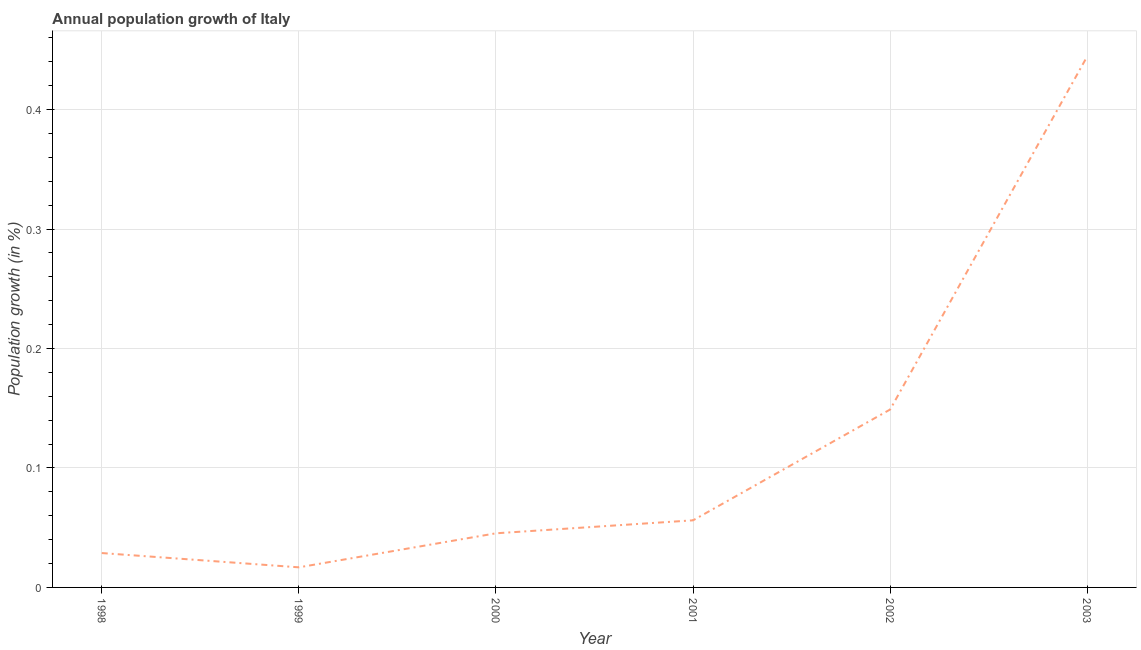What is the population growth in 2003?
Make the answer very short. 0.44. Across all years, what is the maximum population growth?
Make the answer very short. 0.44. Across all years, what is the minimum population growth?
Provide a short and direct response. 0.02. In which year was the population growth minimum?
Offer a terse response. 1999. What is the sum of the population growth?
Your response must be concise. 0.74. What is the difference between the population growth in 1998 and 2001?
Your answer should be compact. -0.03. What is the average population growth per year?
Your answer should be very brief. 0.12. What is the median population growth?
Give a very brief answer. 0.05. What is the ratio of the population growth in 2000 to that in 2001?
Keep it short and to the point. 0.81. Is the population growth in 1998 less than that in 2000?
Keep it short and to the point. Yes. Is the difference between the population growth in 1999 and 2003 greater than the difference between any two years?
Provide a short and direct response. Yes. What is the difference between the highest and the second highest population growth?
Your answer should be compact. 0.3. What is the difference between the highest and the lowest population growth?
Provide a short and direct response. 0.43. Does the graph contain any zero values?
Provide a succinct answer. No. What is the title of the graph?
Ensure brevity in your answer.  Annual population growth of Italy. What is the label or title of the X-axis?
Give a very brief answer. Year. What is the label or title of the Y-axis?
Keep it short and to the point. Population growth (in %). What is the Population growth (in %) of 1998?
Your answer should be compact. 0.03. What is the Population growth (in %) of 1999?
Keep it short and to the point. 0.02. What is the Population growth (in %) in 2000?
Offer a terse response. 0.05. What is the Population growth (in %) in 2001?
Make the answer very short. 0.06. What is the Population growth (in %) of 2002?
Ensure brevity in your answer.  0.15. What is the Population growth (in %) of 2003?
Keep it short and to the point. 0.44. What is the difference between the Population growth (in %) in 1998 and 1999?
Offer a terse response. 0.01. What is the difference between the Population growth (in %) in 1998 and 2000?
Your response must be concise. -0.02. What is the difference between the Population growth (in %) in 1998 and 2001?
Provide a succinct answer. -0.03. What is the difference between the Population growth (in %) in 1998 and 2002?
Make the answer very short. -0.12. What is the difference between the Population growth (in %) in 1998 and 2003?
Give a very brief answer. -0.42. What is the difference between the Population growth (in %) in 1999 and 2000?
Your answer should be compact. -0.03. What is the difference between the Population growth (in %) in 1999 and 2001?
Your answer should be compact. -0.04. What is the difference between the Population growth (in %) in 1999 and 2002?
Make the answer very short. -0.13. What is the difference between the Population growth (in %) in 1999 and 2003?
Ensure brevity in your answer.  -0.43. What is the difference between the Population growth (in %) in 2000 and 2001?
Provide a succinct answer. -0.01. What is the difference between the Population growth (in %) in 2000 and 2002?
Offer a terse response. -0.1. What is the difference between the Population growth (in %) in 2000 and 2003?
Provide a succinct answer. -0.4. What is the difference between the Population growth (in %) in 2001 and 2002?
Offer a very short reply. -0.09. What is the difference between the Population growth (in %) in 2001 and 2003?
Your answer should be compact. -0.39. What is the difference between the Population growth (in %) in 2002 and 2003?
Your response must be concise. -0.3. What is the ratio of the Population growth (in %) in 1998 to that in 1999?
Ensure brevity in your answer.  1.71. What is the ratio of the Population growth (in %) in 1998 to that in 2000?
Offer a very short reply. 0.64. What is the ratio of the Population growth (in %) in 1998 to that in 2001?
Ensure brevity in your answer.  0.51. What is the ratio of the Population growth (in %) in 1998 to that in 2002?
Offer a terse response. 0.19. What is the ratio of the Population growth (in %) in 1998 to that in 2003?
Your answer should be very brief. 0.07. What is the ratio of the Population growth (in %) in 1999 to that in 2000?
Provide a short and direct response. 0.37. What is the ratio of the Population growth (in %) in 1999 to that in 2001?
Offer a terse response. 0.3. What is the ratio of the Population growth (in %) in 1999 to that in 2002?
Your response must be concise. 0.11. What is the ratio of the Population growth (in %) in 1999 to that in 2003?
Ensure brevity in your answer.  0.04. What is the ratio of the Population growth (in %) in 2000 to that in 2001?
Your response must be concise. 0.81. What is the ratio of the Population growth (in %) in 2000 to that in 2002?
Your answer should be very brief. 0.3. What is the ratio of the Population growth (in %) in 2000 to that in 2003?
Provide a short and direct response. 0.1. What is the ratio of the Population growth (in %) in 2001 to that in 2002?
Your answer should be compact. 0.38. What is the ratio of the Population growth (in %) in 2001 to that in 2003?
Your response must be concise. 0.13. What is the ratio of the Population growth (in %) in 2002 to that in 2003?
Keep it short and to the point. 0.34. 